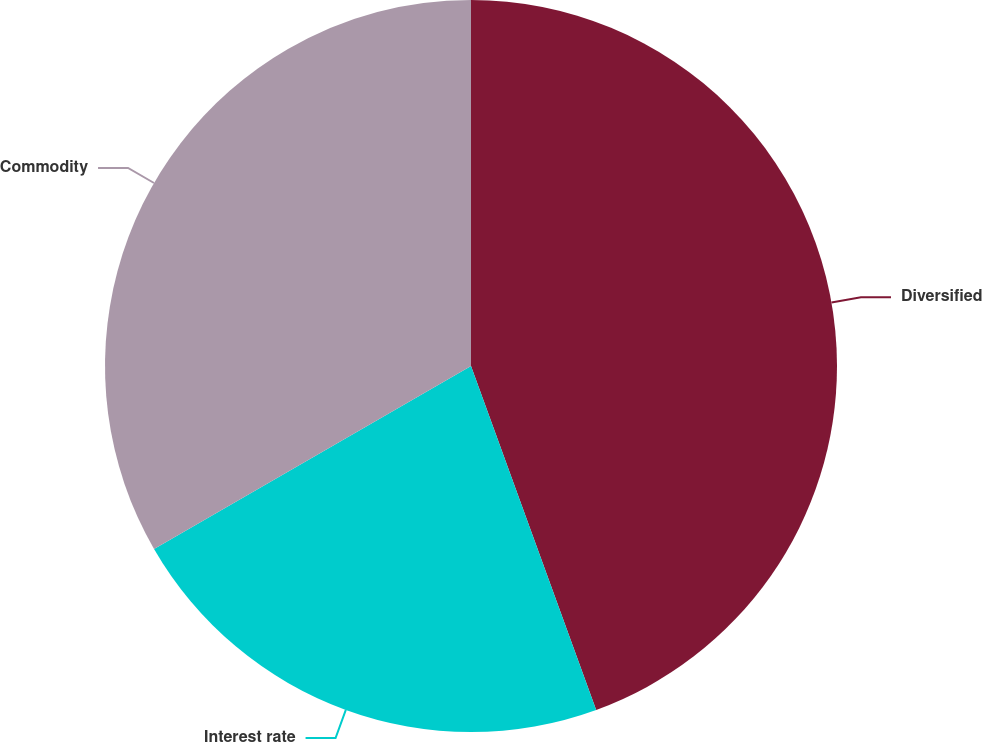Convert chart to OTSL. <chart><loc_0><loc_0><loc_500><loc_500><pie_chart><fcel>Diversified<fcel>Interest rate<fcel>Commodity<nl><fcel>44.44%<fcel>22.22%<fcel>33.33%<nl></chart> 